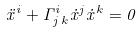Convert formula to latex. <formula><loc_0><loc_0><loc_500><loc_500>\ddot { x } ^ { i } + \Gamma ^ { i } _ { j \, k } \dot { x } ^ { j } \dot { x } ^ { k } = 0</formula> 